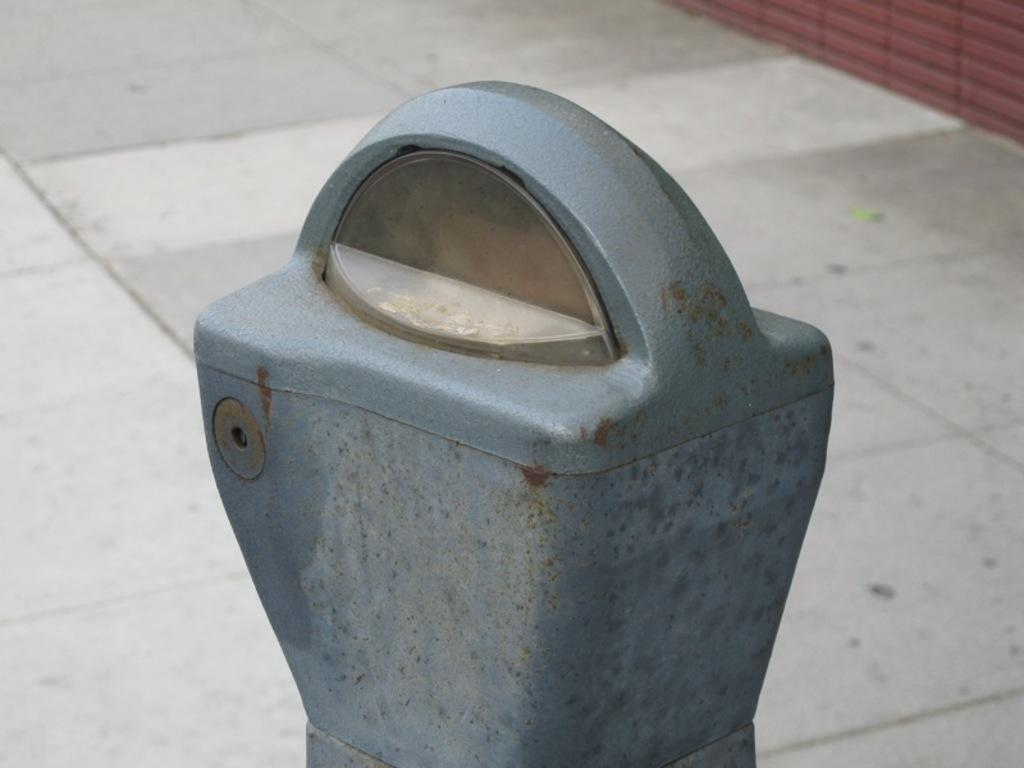What is the main object in the image? There is a pole in the image. Where is the pole situated? The pole is located on a footpath. What type of chalk drawings can be seen on the pole in the image? There is no mention of chalk drawings or any drawings on the pole in the image. 